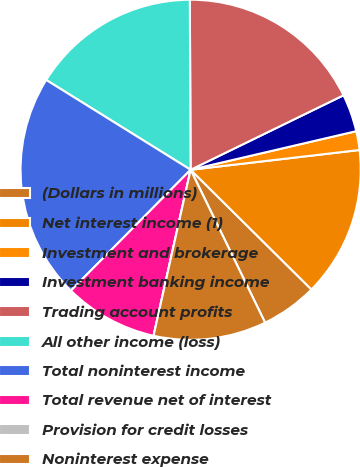<chart> <loc_0><loc_0><loc_500><loc_500><pie_chart><fcel>(Dollars in millions)<fcel>Net interest income (1)<fcel>Investment and brokerage<fcel>Investment banking income<fcel>Trading account profits<fcel>All other income (loss)<fcel>Total noninterest income<fcel>Total revenue net of interest<fcel>Provision for credit losses<fcel>Noninterest expense<nl><fcel>5.36%<fcel>14.28%<fcel>1.79%<fcel>3.57%<fcel>17.86%<fcel>16.07%<fcel>21.43%<fcel>8.93%<fcel>0.0%<fcel>10.71%<nl></chart> 